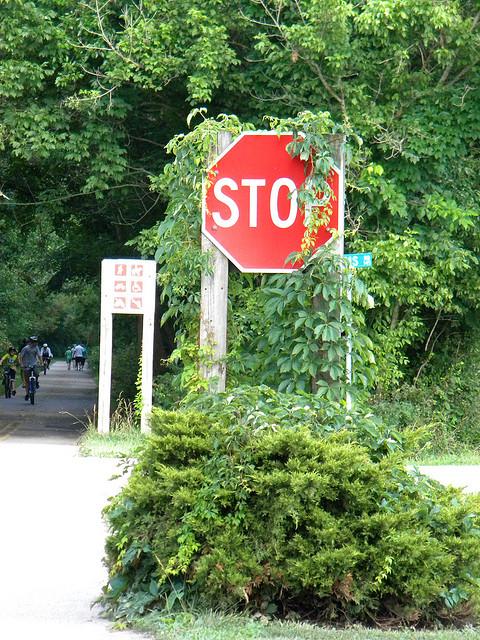Is the foliage around the sign overgrown?
Give a very brief answer. Yes. Are there bicyclists in the photo?
Answer briefly. Yes. What would you do if you came up to this sign while driving a car?
Give a very brief answer. Stop. 